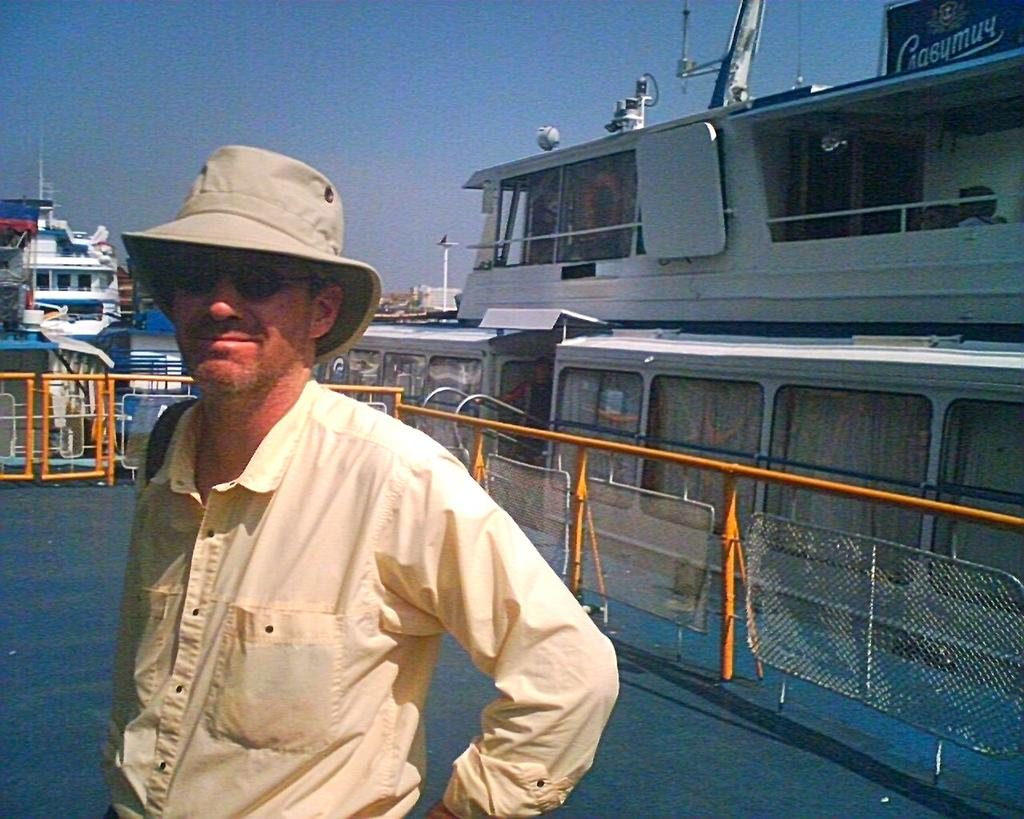What is located on the left side of the image? There is a person on the left side of the image. What is the person wearing on their face? The person is wearing goggles. What type of headwear is the person wearing? The person is wearing a hat. What is the facial expression of the person? The person is smiling. What can be seen in the background of the image? There is a path, rods, a mesh, ships, and the sky visible in the background of the image. Can you see the person's fang in the image? There is no mention of a fang in the image, and people do not have fangs. 